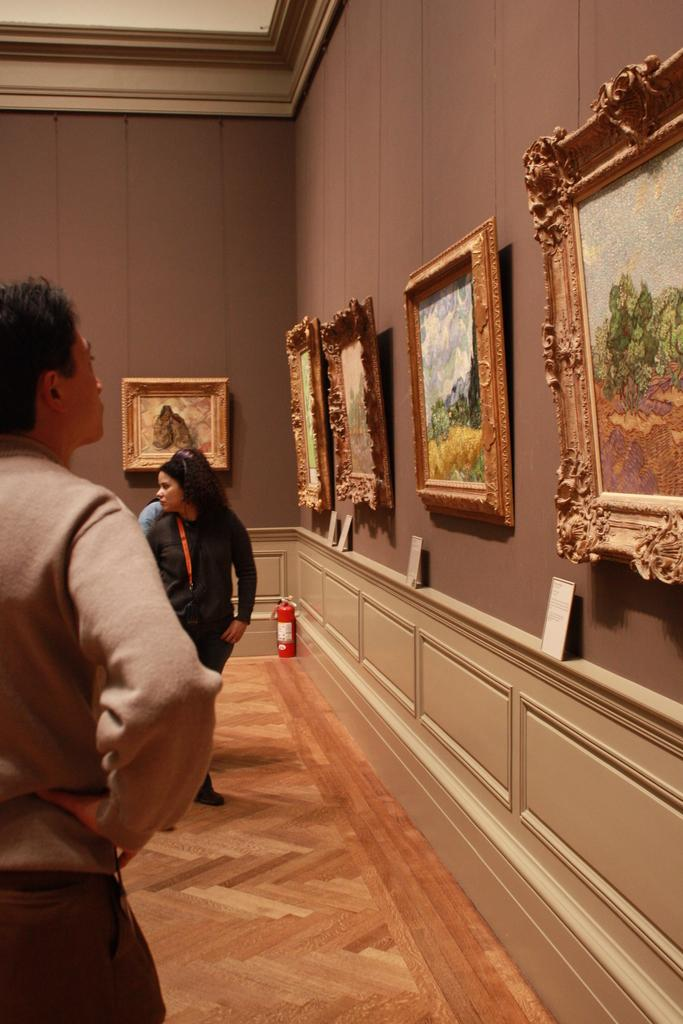What can be seen in the image involving people? There are people standing in the image. Where are the people standing? The people are standing on the floor. What is present on the wall in the image? There are photo frames on the wall. What safety device can be seen on the floor in the image? There is a fire extinguisher on the floor in the image. What type of operation is being performed by the people in the image? There is no operation being performed by the people in the image; they are simply standing. Can you tell me how many spades are visible in the image? There are no spades present in the image. 